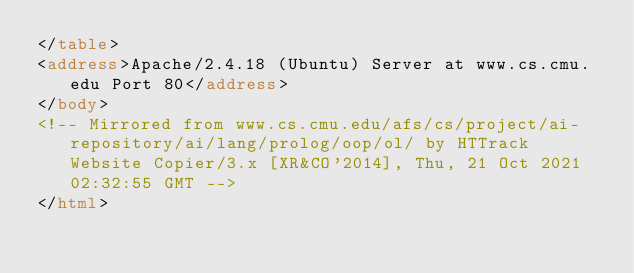Convert code to text. <code><loc_0><loc_0><loc_500><loc_500><_HTML_></table>
<address>Apache/2.4.18 (Ubuntu) Server at www.cs.cmu.edu Port 80</address>
</body>
<!-- Mirrored from www.cs.cmu.edu/afs/cs/project/ai-repository/ai/lang/prolog/oop/ol/ by HTTrack Website Copier/3.x [XR&CO'2014], Thu, 21 Oct 2021 02:32:55 GMT -->
</html>
</code> 